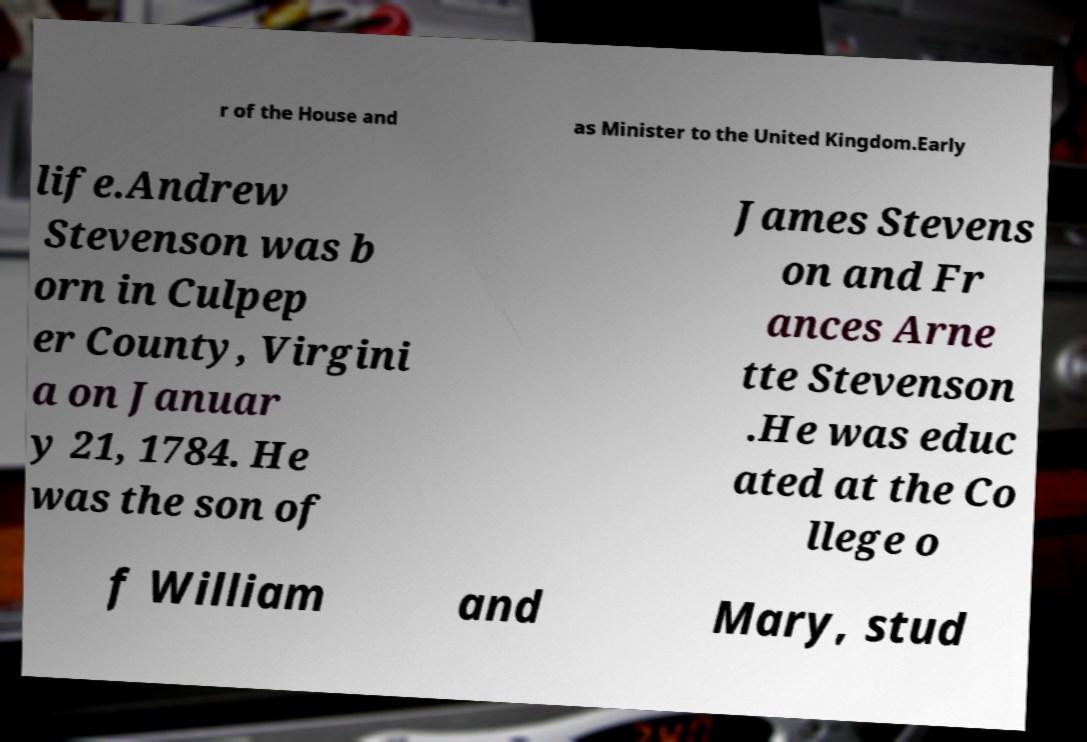Please read and relay the text visible in this image. What does it say? r of the House and as Minister to the United Kingdom.Early life.Andrew Stevenson was b orn in Culpep er County, Virgini a on Januar y 21, 1784. He was the son of James Stevens on and Fr ances Arne tte Stevenson .He was educ ated at the Co llege o f William and Mary, stud 